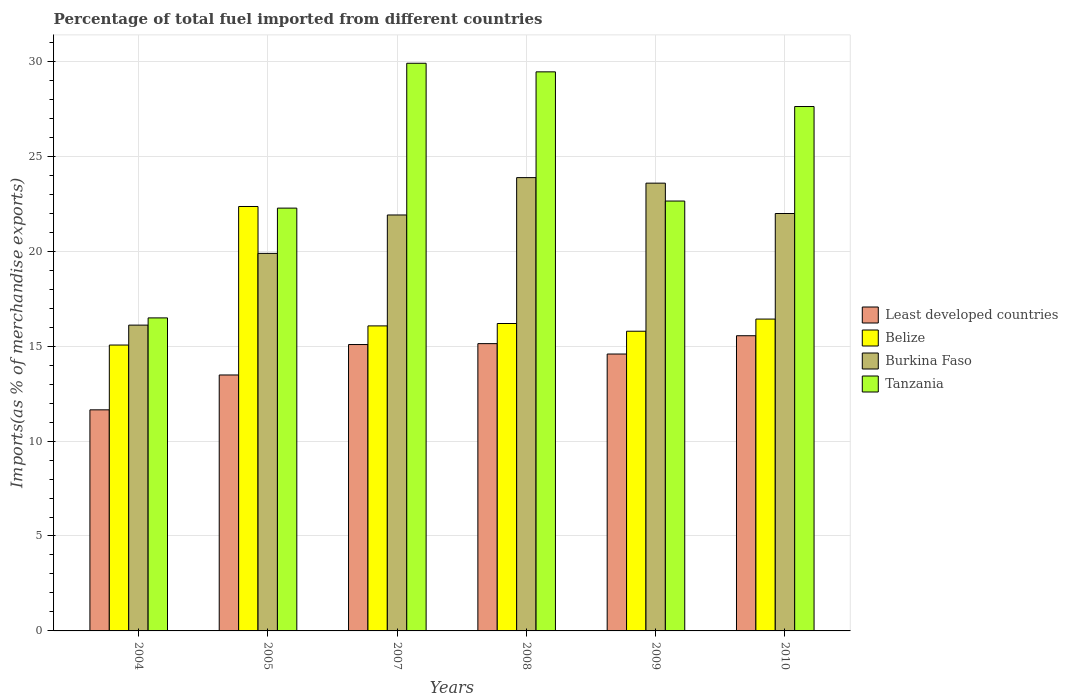How many different coloured bars are there?
Provide a short and direct response. 4. Are the number of bars per tick equal to the number of legend labels?
Provide a short and direct response. Yes. Are the number of bars on each tick of the X-axis equal?
Your answer should be very brief. Yes. How many bars are there on the 6th tick from the right?
Provide a succinct answer. 4. What is the label of the 1st group of bars from the left?
Make the answer very short. 2004. In how many cases, is the number of bars for a given year not equal to the number of legend labels?
Offer a very short reply. 0. What is the percentage of imports to different countries in Least developed countries in 2007?
Provide a succinct answer. 15.08. Across all years, what is the maximum percentage of imports to different countries in Burkina Faso?
Your answer should be very brief. 23.87. Across all years, what is the minimum percentage of imports to different countries in Burkina Faso?
Give a very brief answer. 16.11. In which year was the percentage of imports to different countries in Burkina Faso minimum?
Your answer should be compact. 2004. What is the total percentage of imports to different countries in Tanzania in the graph?
Make the answer very short. 148.36. What is the difference between the percentage of imports to different countries in Tanzania in 2004 and that in 2005?
Your answer should be very brief. -5.78. What is the difference between the percentage of imports to different countries in Burkina Faso in 2010 and the percentage of imports to different countries in Least developed countries in 2009?
Keep it short and to the point. 7.4. What is the average percentage of imports to different countries in Least developed countries per year?
Offer a very short reply. 14.25. In the year 2010, what is the difference between the percentage of imports to different countries in Burkina Faso and percentage of imports to different countries in Tanzania?
Your response must be concise. -5.63. In how many years, is the percentage of imports to different countries in Belize greater than 11 %?
Make the answer very short. 6. What is the ratio of the percentage of imports to different countries in Least developed countries in 2007 to that in 2008?
Make the answer very short. 1. What is the difference between the highest and the second highest percentage of imports to different countries in Tanzania?
Your answer should be compact. 0.45. What is the difference between the highest and the lowest percentage of imports to different countries in Tanzania?
Your answer should be very brief. 13.41. Is the sum of the percentage of imports to different countries in Burkina Faso in 2005 and 2010 greater than the maximum percentage of imports to different countries in Belize across all years?
Provide a short and direct response. Yes. Is it the case that in every year, the sum of the percentage of imports to different countries in Least developed countries and percentage of imports to different countries in Belize is greater than the sum of percentage of imports to different countries in Tanzania and percentage of imports to different countries in Burkina Faso?
Offer a very short reply. No. What does the 2nd bar from the left in 2005 represents?
Offer a terse response. Belize. What does the 2nd bar from the right in 2005 represents?
Keep it short and to the point. Burkina Faso. Is it the case that in every year, the sum of the percentage of imports to different countries in Least developed countries and percentage of imports to different countries in Tanzania is greater than the percentage of imports to different countries in Burkina Faso?
Your response must be concise. Yes. How many bars are there?
Keep it short and to the point. 24. How many years are there in the graph?
Ensure brevity in your answer.  6. Are the values on the major ticks of Y-axis written in scientific E-notation?
Offer a terse response. No. Does the graph contain grids?
Offer a terse response. Yes. How are the legend labels stacked?
Keep it short and to the point. Vertical. What is the title of the graph?
Offer a very short reply. Percentage of total fuel imported from different countries. Does "Cote d'Ivoire" appear as one of the legend labels in the graph?
Your answer should be compact. No. What is the label or title of the Y-axis?
Make the answer very short. Imports(as % of merchandise exports). What is the Imports(as % of merchandise exports) of Least developed countries in 2004?
Keep it short and to the point. 11.64. What is the Imports(as % of merchandise exports) of Belize in 2004?
Keep it short and to the point. 15.06. What is the Imports(as % of merchandise exports) of Burkina Faso in 2004?
Offer a terse response. 16.11. What is the Imports(as % of merchandise exports) in Tanzania in 2004?
Provide a succinct answer. 16.49. What is the Imports(as % of merchandise exports) of Least developed countries in 2005?
Provide a succinct answer. 13.48. What is the Imports(as % of merchandise exports) in Belize in 2005?
Your answer should be compact. 22.35. What is the Imports(as % of merchandise exports) in Burkina Faso in 2005?
Your answer should be very brief. 19.88. What is the Imports(as % of merchandise exports) in Tanzania in 2005?
Ensure brevity in your answer.  22.27. What is the Imports(as % of merchandise exports) of Least developed countries in 2007?
Ensure brevity in your answer.  15.08. What is the Imports(as % of merchandise exports) in Belize in 2007?
Your answer should be compact. 16.06. What is the Imports(as % of merchandise exports) of Burkina Faso in 2007?
Make the answer very short. 21.91. What is the Imports(as % of merchandise exports) in Tanzania in 2007?
Your response must be concise. 29.9. What is the Imports(as % of merchandise exports) of Least developed countries in 2008?
Your answer should be very brief. 15.13. What is the Imports(as % of merchandise exports) in Belize in 2008?
Provide a short and direct response. 16.19. What is the Imports(as % of merchandise exports) of Burkina Faso in 2008?
Provide a succinct answer. 23.87. What is the Imports(as % of merchandise exports) of Tanzania in 2008?
Keep it short and to the point. 29.45. What is the Imports(as % of merchandise exports) of Least developed countries in 2009?
Your response must be concise. 14.58. What is the Imports(as % of merchandise exports) of Belize in 2009?
Offer a very short reply. 15.78. What is the Imports(as % of merchandise exports) of Burkina Faso in 2009?
Offer a terse response. 23.58. What is the Imports(as % of merchandise exports) of Tanzania in 2009?
Ensure brevity in your answer.  22.64. What is the Imports(as % of merchandise exports) of Least developed countries in 2010?
Give a very brief answer. 15.55. What is the Imports(as % of merchandise exports) in Belize in 2010?
Offer a terse response. 16.42. What is the Imports(as % of merchandise exports) of Burkina Faso in 2010?
Your response must be concise. 21.98. What is the Imports(as % of merchandise exports) of Tanzania in 2010?
Offer a very short reply. 27.62. Across all years, what is the maximum Imports(as % of merchandise exports) in Least developed countries?
Offer a very short reply. 15.55. Across all years, what is the maximum Imports(as % of merchandise exports) in Belize?
Your answer should be compact. 22.35. Across all years, what is the maximum Imports(as % of merchandise exports) in Burkina Faso?
Your answer should be compact. 23.87. Across all years, what is the maximum Imports(as % of merchandise exports) of Tanzania?
Provide a succinct answer. 29.9. Across all years, what is the minimum Imports(as % of merchandise exports) of Least developed countries?
Your answer should be compact. 11.64. Across all years, what is the minimum Imports(as % of merchandise exports) in Belize?
Make the answer very short. 15.06. Across all years, what is the minimum Imports(as % of merchandise exports) in Burkina Faso?
Keep it short and to the point. 16.11. Across all years, what is the minimum Imports(as % of merchandise exports) of Tanzania?
Offer a terse response. 16.49. What is the total Imports(as % of merchandise exports) of Least developed countries in the graph?
Provide a succinct answer. 85.47. What is the total Imports(as % of merchandise exports) in Belize in the graph?
Your response must be concise. 101.88. What is the total Imports(as % of merchandise exports) in Burkina Faso in the graph?
Ensure brevity in your answer.  127.34. What is the total Imports(as % of merchandise exports) in Tanzania in the graph?
Give a very brief answer. 148.36. What is the difference between the Imports(as % of merchandise exports) of Least developed countries in 2004 and that in 2005?
Provide a succinct answer. -1.84. What is the difference between the Imports(as % of merchandise exports) in Belize in 2004 and that in 2005?
Keep it short and to the point. -7.3. What is the difference between the Imports(as % of merchandise exports) of Burkina Faso in 2004 and that in 2005?
Provide a succinct answer. -3.78. What is the difference between the Imports(as % of merchandise exports) of Tanzania in 2004 and that in 2005?
Provide a short and direct response. -5.78. What is the difference between the Imports(as % of merchandise exports) in Least developed countries in 2004 and that in 2007?
Your response must be concise. -3.44. What is the difference between the Imports(as % of merchandise exports) of Belize in 2004 and that in 2007?
Ensure brevity in your answer.  -1.01. What is the difference between the Imports(as % of merchandise exports) of Burkina Faso in 2004 and that in 2007?
Ensure brevity in your answer.  -5.8. What is the difference between the Imports(as % of merchandise exports) of Tanzania in 2004 and that in 2007?
Your answer should be very brief. -13.41. What is the difference between the Imports(as % of merchandise exports) of Least developed countries in 2004 and that in 2008?
Ensure brevity in your answer.  -3.49. What is the difference between the Imports(as % of merchandise exports) of Belize in 2004 and that in 2008?
Your answer should be compact. -1.13. What is the difference between the Imports(as % of merchandise exports) of Burkina Faso in 2004 and that in 2008?
Your answer should be compact. -7.77. What is the difference between the Imports(as % of merchandise exports) in Tanzania in 2004 and that in 2008?
Your response must be concise. -12.96. What is the difference between the Imports(as % of merchandise exports) of Least developed countries in 2004 and that in 2009?
Keep it short and to the point. -2.94. What is the difference between the Imports(as % of merchandise exports) of Belize in 2004 and that in 2009?
Make the answer very short. -0.73. What is the difference between the Imports(as % of merchandise exports) in Burkina Faso in 2004 and that in 2009?
Provide a short and direct response. -7.48. What is the difference between the Imports(as % of merchandise exports) in Tanzania in 2004 and that in 2009?
Your answer should be compact. -6.16. What is the difference between the Imports(as % of merchandise exports) of Least developed countries in 2004 and that in 2010?
Give a very brief answer. -3.9. What is the difference between the Imports(as % of merchandise exports) in Belize in 2004 and that in 2010?
Ensure brevity in your answer.  -1.37. What is the difference between the Imports(as % of merchandise exports) of Burkina Faso in 2004 and that in 2010?
Your answer should be compact. -5.88. What is the difference between the Imports(as % of merchandise exports) in Tanzania in 2004 and that in 2010?
Ensure brevity in your answer.  -11.13. What is the difference between the Imports(as % of merchandise exports) of Least developed countries in 2005 and that in 2007?
Your answer should be compact. -1.6. What is the difference between the Imports(as % of merchandise exports) of Belize in 2005 and that in 2007?
Provide a succinct answer. 6.29. What is the difference between the Imports(as % of merchandise exports) of Burkina Faso in 2005 and that in 2007?
Provide a short and direct response. -2.02. What is the difference between the Imports(as % of merchandise exports) of Tanzania in 2005 and that in 2007?
Provide a succinct answer. -7.63. What is the difference between the Imports(as % of merchandise exports) in Least developed countries in 2005 and that in 2008?
Your answer should be compact. -1.65. What is the difference between the Imports(as % of merchandise exports) in Belize in 2005 and that in 2008?
Your answer should be compact. 6.16. What is the difference between the Imports(as % of merchandise exports) in Burkina Faso in 2005 and that in 2008?
Give a very brief answer. -3.99. What is the difference between the Imports(as % of merchandise exports) in Tanzania in 2005 and that in 2008?
Keep it short and to the point. -7.18. What is the difference between the Imports(as % of merchandise exports) of Least developed countries in 2005 and that in 2009?
Keep it short and to the point. -1.1. What is the difference between the Imports(as % of merchandise exports) in Belize in 2005 and that in 2009?
Offer a very short reply. 6.57. What is the difference between the Imports(as % of merchandise exports) in Burkina Faso in 2005 and that in 2009?
Ensure brevity in your answer.  -3.7. What is the difference between the Imports(as % of merchandise exports) in Tanzania in 2005 and that in 2009?
Make the answer very short. -0.37. What is the difference between the Imports(as % of merchandise exports) of Least developed countries in 2005 and that in 2010?
Keep it short and to the point. -2.07. What is the difference between the Imports(as % of merchandise exports) of Belize in 2005 and that in 2010?
Ensure brevity in your answer.  5.93. What is the difference between the Imports(as % of merchandise exports) of Burkina Faso in 2005 and that in 2010?
Provide a short and direct response. -2.1. What is the difference between the Imports(as % of merchandise exports) in Tanzania in 2005 and that in 2010?
Your answer should be compact. -5.35. What is the difference between the Imports(as % of merchandise exports) in Least developed countries in 2007 and that in 2008?
Ensure brevity in your answer.  -0.05. What is the difference between the Imports(as % of merchandise exports) of Belize in 2007 and that in 2008?
Your response must be concise. -0.13. What is the difference between the Imports(as % of merchandise exports) in Burkina Faso in 2007 and that in 2008?
Make the answer very short. -1.97. What is the difference between the Imports(as % of merchandise exports) in Tanzania in 2007 and that in 2008?
Your answer should be very brief. 0.45. What is the difference between the Imports(as % of merchandise exports) in Least developed countries in 2007 and that in 2009?
Make the answer very short. 0.5. What is the difference between the Imports(as % of merchandise exports) in Belize in 2007 and that in 2009?
Your response must be concise. 0.28. What is the difference between the Imports(as % of merchandise exports) of Burkina Faso in 2007 and that in 2009?
Your response must be concise. -1.68. What is the difference between the Imports(as % of merchandise exports) in Tanzania in 2007 and that in 2009?
Offer a very short reply. 7.26. What is the difference between the Imports(as % of merchandise exports) in Least developed countries in 2007 and that in 2010?
Your answer should be compact. -0.46. What is the difference between the Imports(as % of merchandise exports) of Belize in 2007 and that in 2010?
Your answer should be compact. -0.36. What is the difference between the Imports(as % of merchandise exports) in Burkina Faso in 2007 and that in 2010?
Make the answer very short. -0.08. What is the difference between the Imports(as % of merchandise exports) in Tanzania in 2007 and that in 2010?
Offer a terse response. 2.28. What is the difference between the Imports(as % of merchandise exports) of Least developed countries in 2008 and that in 2009?
Make the answer very short. 0.55. What is the difference between the Imports(as % of merchandise exports) of Belize in 2008 and that in 2009?
Provide a short and direct response. 0.41. What is the difference between the Imports(as % of merchandise exports) in Burkina Faso in 2008 and that in 2009?
Provide a short and direct response. 0.29. What is the difference between the Imports(as % of merchandise exports) in Tanzania in 2008 and that in 2009?
Keep it short and to the point. 6.8. What is the difference between the Imports(as % of merchandise exports) of Least developed countries in 2008 and that in 2010?
Make the answer very short. -0.42. What is the difference between the Imports(as % of merchandise exports) of Belize in 2008 and that in 2010?
Offer a very short reply. -0.23. What is the difference between the Imports(as % of merchandise exports) of Burkina Faso in 2008 and that in 2010?
Provide a short and direct response. 1.89. What is the difference between the Imports(as % of merchandise exports) of Tanzania in 2008 and that in 2010?
Provide a succinct answer. 1.83. What is the difference between the Imports(as % of merchandise exports) in Least developed countries in 2009 and that in 2010?
Your answer should be very brief. -0.96. What is the difference between the Imports(as % of merchandise exports) in Belize in 2009 and that in 2010?
Offer a very short reply. -0.64. What is the difference between the Imports(as % of merchandise exports) of Burkina Faso in 2009 and that in 2010?
Your answer should be compact. 1.6. What is the difference between the Imports(as % of merchandise exports) in Tanzania in 2009 and that in 2010?
Provide a short and direct response. -4.98. What is the difference between the Imports(as % of merchandise exports) in Least developed countries in 2004 and the Imports(as % of merchandise exports) in Belize in 2005?
Provide a short and direct response. -10.71. What is the difference between the Imports(as % of merchandise exports) in Least developed countries in 2004 and the Imports(as % of merchandise exports) in Burkina Faso in 2005?
Provide a short and direct response. -8.24. What is the difference between the Imports(as % of merchandise exports) in Least developed countries in 2004 and the Imports(as % of merchandise exports) in Tanzania in 2005?
Provide a succinct answer. -10.62. What is the difference between the Imports(as % of merchandise exports) in Belize in 2004 and the Imports(as % of merchandise exports) in Burkina Faso in 2005?
Offer a terse response. -4.83. What is the difference between the Imports(as % of merchandise exports) of Belize in 2004 and the Imports(as % of merchandise exports) of Tanzania in 2005?
Provide a short and direct response. -7.21. What is the difference between the Imports(as % of merchandise exports) of Burkina Faso in 2004 and the Imports(as % of merchandise exports) of Tanzania in 2005?
Your answer should be compact. -6.16. What is the difference between the Imports(as % of merchandise exports) of Least developed countries in 2004 and the Imports(as % of merchandise exports) of Belize in 2007?
Your response must be concise. -4.42. What is the difference between the Imports(as % of merchandise exports) in Least developed countries in 2004 and the Imports(as % of merchandise exports) in Burkina Faso in 2007?
Make the answer very short. -10.26. What is the difference between the Imports(as % of merchandise exports) of Least developed countries in 2004 and the Imports(as % of merchandise exports) of Tanzania in 2007?
Give a very brief answer. -18.25. What is the difference between the Imports(as % of merchandise exports) in Belize in 2004 and the Imports(as % of merchandise exports) in Burkina Faso in 2007?
Make the answer very short. -6.85. What is the difference between the Imports(as % of merchandise exports) of Belize in 2004 and the Imports(as % of merchandise exports) of Tanzania in 2007?
Make the answer very short. -14.84. What is the difference between the Imports(as % of merchandise exports) of Burkina Faso in 2004 and the Imports(as % of merchandise exports) of Tanzania in 2007?
Offer a terse response. -13.79. What is the difference between the Imports(as % of merchandise exports) of Least developed countries in 2004 and the Imports(as % of merchandise exports) of Belize in 2008?
Offer a very short reply. -4.55. What is the difference between the Imports(as % of merchandise exports) of Least developed countries in 2004 and the Imports(as % of merchandise exports) of Burkina Faso in 2008?
Your answer should be compact. -12.23. What is the difference between the Imports(as % of merchandise exports) in Least developed countries in 2004 and the Imports(as % of merchandise exports) in Tanzania in 2008?
Your answer should be very brief. -17.8. What is the difference between the Imports(as % of merchandise exports) in Belize in 2004 and the Imports(as % of merchandise exports) in Burkina Faso in 2008?
Your response must be concise. -8.82. What is the difference between the Imports(as % of merchandise exports) of Belize in 2004 and the Imports(as % of merchandise exports) of Tanzania in 2008?
Offer a very short reply. -14.39. What is the difference between the Imports(as % of merchandise exports) in Burkina Faso in 2004 and the Imports(as % of merchandise exports) in Tanzania in 2008?
Provide a short and direct response. -13.34. What is the difference between the Imports(as % of merchandise exports) in Least developed countries in 2004 and the Imports(as % of merchandise exports) in Belize in 2009?
Your answer should be very brief. -4.14. What is the difference between the Imports(as % of merchandise exports) in Least developed countries in 2004 and the Imports(as % of merchandise exports) in Burkina Faso in 2009?
Keep it short and to the point. -11.94. What is the difference between the Imports(as % of merchandise exports) of Least developed countries in 2004 and the Imports(as % of merchandise exports) of Tanzania in 2009?
Provide a short and direct response. -11. What is the difference between the Imports(as % of merchandise exports) in Belize in 2004 and the Imports(as % of merchandise exports) in Burkina Faso in 2009?
Keep it short and to the point. -8.53. What is the difference between the Imports(as % of merchandise exports) in Belize in 2004 and the Imports(as % of merchandise exports) in Tanzania in 2009?
Your answer should be compact. -7.58. What is the difference between the Imports(as % of merchandise exports) in Burkina Faso in 2004 and the Imports(as % of merchandise exports) in Tanzania in 2009?
Give a very brief answer. -6.54. What is the difference between the Imports(as % of merchandise exports) of Least developed countries in 2004 and the Imports(as % of merchandise exports) of Belize in 2010?
Make the answer very short. -4.78. What is the difference between the Imports(as % of merchandise exports) in Least developed countries in 2004 and the Imports(as % of merchandise exports) in Burkina Faso in 2010?
Provide a short and direct response. -10.34. What is the difference between the Imports(as % of merchandise exports) in Least developed countries in 2004 and the Imports(as % of merchandise exports) in Tanzania in 2010?
Give a very brief answer. -15.97. What is the difference between the Imports(as % of merchandise exports) in Belize in 2004 and the Imports(as % of merchandise exports) in Burkina Faso in 2010?
Keep it short and to the point. -6.93. What is the difference between the Imports(as % of merchandise exports) in Belize in 2004 and the Imports(as % of merchandise exports) in Tanzania in 2010?
Offer a terse response. -12.56. What is the difference between the Imports(as % of merchandise exports) in Burkina Faso in 2004 and the Imports(as % of merchandise exports) in Tanzania in 2010?
Your answer should be compact. -11.51. What is the difference between the Imports(as % of merchandise exports) of Least developed countries in 2005 and the Imports(as % of merchandise exports) of Belize in 2007?
Provide a short and direct response. -2.58. What is the difference between the Imports(as % of merchandise exports) of Least developed countries in 2005 and the Imports(as % of merchandise exports) of Burkina Faso in 2007?
Your answer should be very brief. -8.43. What is the difference between the Imports(as % of merchandise exports) in Least developed countries in 2005 and the Imports(as % of merchandise exports) in Tanzania in 2007?
Make the answer very short. -16.42. What is the difference between the Imports(as % of merchandise exports) in Belize in 2005 and the Imports(as % of merchandise exports) in Burkina Faso in 2007?
Provide a short and direct response. 0.45. What is the difference between the Imports(as % of merchandise exports) of Belize in 2005 and the Imports(as % of merchandise exports) of Tanzania in 2007?
Offer a very short reply. -7.54. What is the difference between the Imports(as % of merchandise exports) of Burkina Faso in 2005 and the Imports(as % of merchandise exports) of Tanzania in 2007?
Offer a terse response. -10.01. What is the difference between the Imports(as % of merchandise exports) of Least developed countries in 2005 and the Imports(as % of merchandise exports) of Belize in 2008?
Provide a short and direct response. -2.71. What is the difference between the Imports(as % of merchandise exports) of Least developed countries in 2005 and the Imports(as % of merchandise exports) of Burkina Faso in 2008?
Give a very brief answer. -10.39. What is the difference between the Imports(as % of merchandise exports) of Least developed countries in 2005 and the Imports(as % of merchandise exports) of Tanzania in 2008?
Provide a succinct answer. -15.97. What is the difference between the Imports(as % of merchandise exports) in Belize in 2005 and the Imports(as % of merchandise exports) in Burkina Faso in 2008?
Offer a terse response. -1.52. What is the difference between the Imports(as % of merchandise exports) of Belize in 2005 and the Imports(as % of merchandise exports) of Tanzania in 2008?
Provide a short and direct response. -7.09. What is the difference between the Imports(as % of merchandise exports) of Burkina Faso in 2005 and the Imports(as % of merchandise exports) of Tanzania in 2008?
Your answer should be very brief. -9.56. What is the difference between the Imports(as % of merchandise exports) in Least developed countries in 2005 and the Imports(as % of merchandise exports) in Belize in 2009?
Provide a short and direct response. -2.3. What is the difference between the Imports(as % of merchandise exports) of Least developed countries in 2005 and the Imports(as % of merchandise exports) of Burkina Faso in 2009?
Your response must be concise. -10.1. What is the difference between the Imports(as % of merchandise exports) of Least developed countries in 2005 and the Imports(as % of merchandise exports) of Tanzania in 2009?
Your answer should be very brief. -9.16. What is the difference between the Imports(as % of merchandise exports) in Belize in 2005 and the Imports(as % of merchandise exports) in Burkina Faso in 2009?
Offer a very short reply. -1.23. What is the difference between the Imports(as % of merchandise exports) of Belize in 2005 and the Imports(as % of merchandise exports) of Tanzania in 2009?
Your answer should be compact. -0.29. What is the difference between the Imports(as % of merchandise exports) in Burkina Faso in 2005 and the Imports(as % of merchandise exports) in Tanzania in 2009?
Offer a very short reply. -2.76. What is the difference between the Imports(as % of merchandise exports) of Least developed countries in 2005 and the Imports(as % of merchandise exports) of Belize in 2010?
Provide a succinct answer. -2.94. What is the difference between the Imports(as % of merchandise exports) in Least developed countries in 2005 and the Imports(as % of merchandise exports) in Burkina Faso in 2010?
Keep it short and to the point. -8.5. What is the difference between the Imports(as % of merchandise exports) of Least developed countries in 2005 and the Imports(as % of merchandise exports) of Tanzania in 2010?
Make the answer very short. -14.14. What is the difference between the Imports(as % of merchandise exports) in Belize in 2005 and the Imports(as % of merchandise exports) in Burkina Faso in 2010?
Your answer should be very brief. 0.37. What is the difference between the Imports(as % of merchandise exports) of Belize in 2005 and the Imports(as % of merchandise exports) of Tanzania in 2010?
Make the answer very short. -5.27. What is the difference between the Imports(as % of merchandise exports) of Burkina Faso in 2005 and the Imports(as % of merchandise exports) of Tanzania in 2010?
Ensure brevity in your answer.  -7.74. What is the difference between the Imports(as % of merchandise exports) of Least developed countries in 2007 and the Imports(as % of merchandise exports) of Belize in 2008?
Provide a short and direct response. -1.11. What is the difference between the Imports(as % of merchandise exports) in Least developed countries in 2007 and the Imports(as % of merchandise exports) in Burkina Faso in 2008?
Ensure brevity in your answer.  -8.79. What is the difference between the Imports(as % of merchandise exports) of Least developed countries in 2007 and the Imports(as % of merchandise exports) of Tanzania in 2008?
Your answer should be very brief. -14.36. What is the difference between the Imports(as % of merchandise exports) in Belize in 2007 and the Imports(as % of merchandise exports) in Burkina Faso in 2008?
Provide a succinct answer. -7.81. What is the difference between the Imports(as % of merchandise exports) in Belize in 2007 and the Imports(as % of merchandise exports) in Tanzania in 2008?
Ensure brevity in your answer.  -13.38. What is the difference between the Imports(as % of merchandise exports) of Burkina Faso in 2007 and the Imports(as % of merchandise exports) of Tanzania in 2008?
Offer a terse response. -7.54. What is the difference between the Imports(as % of merchandise exports) in Least developed countries in 2007 and the Imports(as % of merchandise exports) in Belize in 2009?
Keep it short and to the point. -0.7. What is the difference between the Imports(as % of merchandise exports) of Least developed countries in 2007 and the Imports(as % of merchandise exports) of Burkina Faso in 2009?
Offer a very short reply. -8.5. What is the difference between the Imports(as % of merchandise exports) in Least developed countries in 2007 and the Imports(as % of merchandise exports) in Tanzania in 2009?
Make the answer very short. -7.56. What is the difference between the Imports(as % of merchandise exports) in Belize in 2007 and the Imports(as % of merchandise exports) in Burkina Faso in 2009?
Provide a succinct answer. -7.52. What is the difference between the Imports(as % of merchandise exports) in Belize in 2007 and the Imports(as % of merchandise exports) in Tanzania in 2009?
Provide a short and direct response. -6.58. What is the difference between the Imports(as % of merchandise exports) in Burkina Faso in 2007 and the Imports(as % of merchandise exports) in Tanzania in 2009?
Provide a succinct answer. -0.73. What is the difference between the Imports(as % of merchandise exports) in Least developed countries in 2007 and the Imports(as % of merchandise exports) in Belize in 2010?
Your answer should be compact. -1.34. What is the difference between the Imports(as % of merchandise exports) in Least developed countries in 2007 and the Imports(as % of merchandise exports) in Burkina Faso in 2010?
Provide a short and direct response. -6.9. What is the difference between the Imports(as % of merchandise exports) in Least developed countries in 2007 and the Imports(as % of merchandise exports) in Tanzania in 2010?
Offer a terse response. -12.54. What is the difference between the Imports(as % of merchandise exports) of Belize in 2007 and the Imports(as % of merchandise exports) of Burkina Faso in 2010?
Provide a succinct answer. -5.92. What is the difference between the Imports(as % of merchandise exports) in Belize in 2007 and the Imports(as % of merchandise exports) in Tanzania in 2010?
Offer a very short reply. -11.55. What is the difference between the Imports(as % of merchandise exports) of Burkina Faso in 2007 and the Imports(as % of merchandise exports) of Tanzania in 2010?
Give a very brief answer. -5.71. What is the difference between the Imports(as % of merchandise exports) in Least developed countries in 2008 and the Imports(as % of merchandise exports) in Belize in 2009?
Your answer should be compact. -0.65. What is the difference between the Imports(as % of merchandise exports) of Least developed countries in 2008 and the Imports(as % of merchandise exports) of Burkina Faso in 2009?
Offer a very short reply. -8.45. What is the difference between the Imports(as % of merchandise exports) of Least developed countries in 2008 and the Imports(as % of merchandise exports) of Tanzania in 2009?
Keep it short and to the point. -7.51. What is the difference between the Imports(as % of merchandise exports) in Belize in 2008 and the Imports(as % of merchandise exports) in Burkina Faso in 2009?
Ensure brevity in your answer.  -7.39. What is the difference between the Imports(as % of merchandise exports) in Belize in 2008 and the Imports(as % of merchandise exports) in Tanzania in 2009?
Your answer should be very brief. -6.45. What is the difference between the Imports(as % of merchandise exports) in Burkina Faso in 2008 and the Imports(as % of merchandise exports) in Tanzania in 2009?
Give a very brief answer. 1.23. What is the difference between the Imports(as % of merchandise exports) of Least developed countries in 2008 and the Imports(as % of merchandise exports) of Belize in 2010?
Keep it short and to the point. -1.29. What is the difference between the Imports(as % of merchandise exports) in Least developed countries in 2008 and the Imports(as % of merchandise exports) in Burkina Faso in 2010?
Provide a succinct answer. -6.85. What is the difference between the Imports(as % of merchandise exports) of Least developed countries in 2008 and the Imports(as % of merchandise exports) of Tanzania in 2010?
Make the answer very short. -12.49. What is the difference between the Imports(as % of merchandise exports) of Belize in 2008 and the Imports(as % of merchandise exports) of Burkina Faso in 2010?
Your response must be concise. -5.79. What is the difference between the Imports(as % of merchandise exports) of Belize in 2008 and the Imports(as % of merchandise exports) of Tanzania in 2010?
Keep it short and to the point. -11.43. What is the difference between the Imports(as % of merchandise exports) of Burkina Faso in 2008 and the Imports(as % of merchandise exports) of Tanzania in 2010?
Provide a succinct answer. -3.74. What is the difference between the Imports(as % of merchandise exports) of Least developed countries in 2009 and the Imports(as % of merchandise exports) of Belize in 2010?
Ensure brevity in your answer.  -1.84. What is the difference between the Imports(as % of merchandise exports) of Least developed countries in 2009 and the Imports(as % of merchandise exports) of Burkina Faso in 2010?
Offer a very short reply. -7.4. What is the difference between the Imports(as % of merchandise exports) in Least developed countries in 2009 and the Imports(as % of merchandise exports) in Tanzania in 2010?
Offer a terse response. -13.04. What is the difference between the Imports(as % of merchandise exports) in Belize in 2009 and the Imports(as % of merchandise exports) in Burkina Faso in 2010?
Your answer should be very brief. -6.2. What is the difference between the Imports(as % of merchandise exports) of Belize in 2009 and the Imports(as % of merchandise exports) of Tanzania in 2010?
Your answer should be compact. -11.83. What is the difference between the Imports(as % of merchandise exports) in Burkina Faso in 2009 and the Imports(as % of merchandise exports) in Tanzania in 2010?
Your response must be concise. -4.04. What is the average Imports(as % of merchandise exports) of Least developed countries per year?
Provide a short and direct response. 14.25. What is the average Imports(as % of merchandise exports) in Belize per year?
Ensure brevity in your answer.  16.98. What is the average Imports(as % of merchandise exports) of Burkina Faso per year?
Offer a terse response. 21.22. What is the average Imports(as % of merchandise exports) in Tanzania per year?
Offer a very short reply. 24.73. In the year 2004, what is the difference between the Imports(as % of merchandise exports) in Least developed countries and Imports(as % of merchandise exports) in Belize?
Provide a short and direct response. -3.41. In the year 2004, what is the difference between the Imports(as % of merchandise exports) in Least developed countries and Imports(as % of merchandise exports) in Burkina Faso?
Provide a succinct answer. -4.46. In the year 2004, what is the difference between the Imports(as % of merchandise exports) in Least developed countries and Imports(as % of merchandise exports) in Tanzania?
Your answer should be very brief. -4.84. In the year 2004, what is the difference between the Imports(as % of merchandise exports) of Belize and Imports(as % of merchandise exports) of Burkina Faso?
Keep it short and to the point. -1.05. In the year 2004, what is the difference between the Imports(as % of merchandise exports) in Belize and Imports(as % of merchandise exports) in Tanzania?
Make the answer very short. -1.43. In the year 2004, what is the difference between the Imports(as % of merchandise exports) of Burkina Faso and Imports(as % of merchandise exports) of Tanzania?
Provide a short and direct response. -0.38. In the year 2005, what is the difference between the Imports(as % of merchandise exports) in Least developed countries and Imports(as % of merchandise exports) in Belize?
Provide a succinct answer. -8.87. In the year 2005, what is the difference between the Imports(as % of merchandise exports) of Least developed countries and Imports(as % of merchandise exports) of Burkina Faso?
Ensure brevity in your answer.  -6.4. In the year 2005, what is the difference between the Imports(as % of merchandise exports) in Least developed countries and Imports(as % of merchandise exports) in Tanzania?
Keep it short and to the point. -8.79. In the year 2005, what is the difference between the Imports(as % of merchandise exports) of Belize and Imports(as % of merchandise exports) of Burkina Faso?
Provide a short and direct response. 2.47. In the year 2005, what is the difference between the Imports(as % of merchandise exports) of Belize and Imports(as % of merchandise exports) of Tanzania?
Your response must be concise. 0.09. In the year 2005, what is the difference between the Imports(as % of merchandise exports) in Burkina Faso and Imports(as % of merchandise exports) in Tanzania?
Make the answer very short. -2.38. In the year 2007, what is the difference between the Imports(as % of merchandise exports) in Least developed countries and Imports(as % of merchandise exports) in Belize?
Keep it short and to the point. -0.98. In the year 2007, what is the difference between the Imports(as % of merchandise exports) in Least developed countries and Imports(as % of merchandise exports) in Burkina Faso?
Provide a short and direct response. -6.82. In the year 2007, what is the difference between the Imports(as % of merchandise exports) of Least developed countries and Imports(as % of merchandise exports) of Tanzania?
Your response must be concise. -14.81. In the year 2007, what is the difference between the Imports(as % of merchandise exports) in Belize and Imports(as % of merchandise exports) in Burkina Faso?
Provide a short and direct response. -5.84. In the year 2007, what is the difference between the Imports(as % of merchandise exports) of Belize and Imports(as % of merchandise exports) of Tanzania?
Offer a very short reply. -13.83. In the year 2007, what is the difference between the Imports(as % of merchandise exports) in Burkina Faso and Imports(as % of merchandise exports) in Tanzania?
Your response must be concise. -7.99. In the year 2008, what is the difference between the Imports(as % of merchandise exports) in Least developed countries and Imports(as % of merchandise exports) in Belize?
Your answer should be very brief. -1.06. In the year 2008, what is the difference between the Imports(as % of merchandise exports) in Least developed countries and Imports(as % of merchandise exports) in Burkina Faso?
Offer a very short reply. -8.74. In the year 2008, what is the difference between the Imports(as % of merchandise exports) of Least developed countries and Imports(as % of merchandise exports) of Tanzania?
Give a very brief answer. -14.31. In the year 2008, what is the difference between the Imports(as % of merchandise exports) in Belize and Imports(as % of merchandise exports) in Burkina Faso?
Your answer should be very brief. -7.68. In the year 2008, what is the difference between the Imports(as % of merchandise exports) of Belize and Imports(as % of merchandise exports) of Tanzania?
Make the answer very short. -13.25. In the year 2008, what is the difference between the Imports(as % of merchandise exports) of Burkina Faso and Imports(as % of merchandise exports) of Tanzania?
Provide a succinct answer. -5.57. In the year 2009, what is the difference between the Imports(as % of merchandise exports) in Least developed countries and Imports(as % of merchandise exports) in Belize?
Offer a terse response. -1.2. In the year 2009, what is the difference between the Imports(as % of merchandise exports) of Least developed countries and Imports(as % of merchandise exports) of Burkina Faso?
Your answer should be compact. -9. In the year 2009, what is the difference between the Imports(as % of merchandise exports) in Least developed countries and Imports(as % of merchandise exports) in Tanzania?
Offer a terse response. -8.06. In the year 2009, what is the difference between the Imports(as % of merchandise exports) of Belize and Imports(as % of merchandise exports) of Burkina Faso?
Your answer should be very brief. -7.8. In the year 2009, what is the difference between the Imports(as % of merchandise exports) in Belize and Imports(as % of merchandise exports) in Tanzania?
Ensure brevity in your answer.  -6.86. In the year 2009, what is the difference between the Imports(as % of merchandise exports) of Burkina Faso and Imports(as % of merchandise exports) of Tanzania?
Offer a very short reply. 0.94. In the year 2010, what is the difference between the Imports(as % of merchandise exports) in Least developed countries and Imports(as % of merchandise exports) in Belize?
Offer a very short reply. -0.88. In the year 2010, what is the difference between the Imports(as % of merchandise exports) of Least developed countries and Imports(as % of merchandise exports) of Burkina Faso?
Make the answer very short. -6.44. In the year 2010, what is the difference between the Imports(as % of merchandise exports) of Least developed countries and Imports(as % of merchandise exports) of Tanzania?
Give a very brief answer. -12.07. In the year 2010, what is the difference between the Imports(as % of merchandise exports) in Belize and Imports(as % of merchandise exports) in Burkina Faso?
Ensure brevity in your answer.  -5.56. In the year 2010, what is the difference between the Imports(as % of merchandise exports) in Belize and Imports(as % of merchandise exports) in Tanzania?
Provide a short and direct response. -11.19. In the year 2010, what is the difference between the Imports(as % of merchandise exports) of Burkina Faso and Imports(as % of merchandise exports) of Tanzania?
Ensure brevity in your answer.  -5.63. What is the ratio of the Imports(as % of merchandise exports) in Least developed countries in 2004 to that in 2005?
Make the answer very short. 0.86. What is the ratio of the Imports(as % of merchandise exports) in Belize in 2004 to that in 2005?
Your response must be concise. 0.67. What is the ratio of the Imports(as % of merchandise exports) in Burkina Faso in 2004 to that in 2005?
Keep it short and to the point. 0.81. What is the ratio of the Imports(as % of merchandise exports) in Tanzania in 2004 to that in 2005?
Give a very brief answer. 0.74. What is the ratio of the Imports(as % of merchandise exports) in Least developed countries in 2004 to that in 2007?
Make the answer very short. 0.77. What is the ratio of the Imports(as % of merchandise exports) in Belize in 2004 to that in 2007?
Offer a very short reply. 0.94. What is the ratio of the Imports(as % of merchandise exports) of Burkina Faso in 2004 to that in 2007?
Your answer should be compact. 0.74. What is the ratio of the Imports(as % of merchandise exports) of Tanzania in 2004 to that in 2007?
Your answer should be compact. 0.55. What is the ratio of the Imports(as % of merchandise exports) of Least developed countries in 2004 to that in 2008?
Make the answer very short. 0.77. What is the ratio of the Imports(as % of merchandise exports) of Belize in 2004 to that in 2008?
Offer a terse response. 0.93. What is the ratio of the Imports(as % of merchandise exports) in Burkina Faso in 2004 to that in 2008?
Offer a very short reply. 0.67. What is the ratio of the Imports(as % of merchandise exports) in Tanzania in 2004 to that in 2008?
Your answer should be compact. 0.56. What is the ratio of the Imports(as % of merchandise exports) in Least developed countries in 2004 to that in 2009?
Provide a short and direct response. 0.8. What is the ratio of the Imports(as % of merchandise exports) of Belize in 2004 to that in 2009?
Keep it short and to the point. 0.95. What is the ratio of the Imports(as % of merchandise exports) of Burkina Faso in 2004 to that in 2009?
Give a very brief answer. 0.68. What is the ratio of the Imports(as % of merchandise exports) in Tanzania in 2004 to that in 2009?
Offer a terse response. 0.73. What is the ratio of the Imports(as % of merchandise exports) of Least developed countries in 2004 to that in 2010?
Provide a short and direct response. 0.75. What is the ratio of the Imports(as % of merchandise exports) in Burkina Faso in 2004 to that in 2010?
Provide a short and direct response. 0.73. What is the ratio of the Imports(as % of merchandise exports) of Tanzania in 2004 to that in 2010?
Offer a very short reply. 0.6. What is the ratio of the Imports(as % of merchandise exports) of Least developed countries in 2005 to that in 2007?
Your answer should be compact. 0.89. What is the ratio of the Imports(as % of merchandise exports) in Belize in 2005 to that in 2007?
Offer a terse response. 1.39. What is the ratio of the Imports(as % of merchandise exports) of Burkina Faso in 2005 to that in 2007?
Offer a terse response. 0.91. What is the ratio of the Imports(as % of merchandise exports) in Tanzania in 2005 to that in 2007?
Provide a short and direct response. 0.74. What is the ratio of the Imports(as % of merchandise exports) in Least developed countries in 2005 to that in 2008?
Make the answer very short. 0.89. What is the ratio of the Imports(as % of merchandise exports) of Belize in 2005 to that in 2008?
Offer a very short reply. 1.38. What is the ratio of the Imports(as % of merchandise exports) of Burkina Faso in 2005 to that in 2008?
Provide a short and direct response. 0.83. What is the ratio of the Imports(as % of merchandise exports) in Tanzania in 2005 to that in 2008?
Your answer should be compact. 0.76. What is the ratio of the Imports(as % of merchandise exports) of Least developed countries in 2005 to that in 2009?
Provide a succinct answer. 0.92. What is the ratio of the Imports(as % of merchandise exports) in Belize in 2005 to that in 2009?
Provide a short and direct response. 1.42. What is the ratio of the Imports(as % of merchandise exports) of Burkina Faso in 2005 to that in 2009?
Provide a short and direct response. 0.84. What is the ratio of the Imports(as % of merchandise exports) in Tanzania in 2005 to that in 2009?
Provide a short and direct response. 0.98. What is the ratio of the Imports(as % of merchandise exports) in Least developed countries in 2005 to that in 2010?
Give a very brief answer. 0.87. What is the ratio of the Imports(as % of merchandise exports) in Belize in 2005 to that in 2010?
Your answer should be compact. 1.36. What is the ratio of the Imports(as % of merchandise exports) of Burkina Faso in 2005 to that in 2010?
Offer a very short reply. 0.9. What is the ratio of the Imports(as % of merchandise exports) of Tanzania in 2005 to that in 2010?
Provide a succinct answer. 0.81. What is the ratio of the Imports(as % of merchandise exports) in Burkina Faso in 2007 to that in 2008?
Your answer should be very brief. 0.92. What is the ratio of the Imports(as % of merchandise exports) of Tanzania in 2007 to that in 2008?
Keep it short and to the point. 1.02. What is the ratio of the Imports(as % of merchandise exports) in Least developed countries in 2007 to that in 2009?
Give a very brief answer. 1.03. What is the ratio of the Imports(as % of merchandise exports) in Belize in 2007 to that in 2009?
Keep it short and to the point. 1.02. What is the ratio of the Imports(as % of merchandise exports) of Burkina Faso in 2007 to that in 2009?
Make the answer very short. 0.93. What is the ratio of the Imports(as % of merchandise exports) in Tanzania in 2007 to that in 2009?
Offer a terse response. 1.32. What is the ratio of the Imports(as % of merchandise exports) in Least developed countries in 2007 to that in 2010?
Give a very brief answer. 0.97. What is the ratio of the Imports(as % of merchandise exports) in Belize in 2007 to that in 2010?
Your answer should be compact. 0.98. What is the ratio of the Imports(as % of merchandise exports) of Tanzania in 2007 to that in 2010?
Your response must be concise. 1.08. What is the ratio of the Imports(as % of merchandise exports) of Least developed countries in 2008 to that in 2009?
Your response must be concise. 1.04. What is the ratio of the Imports(as % of merchandise exports) in Belize in 2008 to that in 2009?
Provide a short and direct response. 1.03. What is the ratio of the Imports(as % of merchandise exports) of Burkina Faso in 2008 to that in 2009?
Make the answer very short. 1.01. What is the ratio of the Imports(as % of merchandise exports) in Tanzania in 2008 to that in 2009?
Your answer should be compact. 1.3. What is the ratio of the Imports(as % of merchandise exports) of Least developed countries in 2008 to that in 2010?
Offer a terse response. 0.97. What is the ratio of the Imports(as % of merchandise exports) in Belize in 2008 to that in 2010?
Offer a terse response. 0.99. What is the ratio of the Imports(as % of merchandise exports) in Burkina Faso in 2008 to that in 2010?
Provide a short and direct response. 1.09. What is the ratio of the Imports(as % of merchandise exports) of Tanzania in 2008 to that in 2010?
Give a very brief answer. 1.07. What is the ratio of the Imports(as % of merchandise exports) of Least developed countries in 2009 to that in 2010?
Make the answer very short. 0.94. What is the ratio of the Imports(as % of merchandise exports) of Belize in 2009 to that in 2010?
Offer a terse response. 0.96. What is the ratio of the Imports(as % of merchandise exports) in Burkina Faso in 2009 to that in 2010?
Provide a succinct answer. 1.07. What is the ratio of the Imports(as % of merchandise exports) in Tanzania in 2009 to that in 2010?
Your answer should be compact. 0.82. What is the difference between the highest and the second highest Imports(as % of merchandise exports) in Least developed countries?
Your answer should be very brief. 0.42. What is the difference between the highest and the second highest Imports(as % of merchandise exports) in Belize?
Keep it short and to the point. 5.93. What is the difference between the highest and the second highest Imports(as % of merchandise exports) of Burkina Faso?
Your answer should be very brief. 0.29. What is the difference between the highest and the second highest Imports(as % of merchandise exports) in Tanzania?
Offer a terse response. 0.45. What is the difference between the highest and the lowest Imports(as % of merchandise exports) in Least developed countries?
Give a very brief answer. 3.9. What is the difference between the highest and the lowest Imports(as % of merchandise exports) of Belize?
Give a very brief answer. 7.3. What is the difference between the highest and the lowest Imports(as % of merchandise exports) in Burkina Faso?
Provide a succinct answer. 7.77. What is the difference between the highest and the lowest Imports(as % of merchandise exports) in Tanzania?
Your answer should be compact. 13.41. 